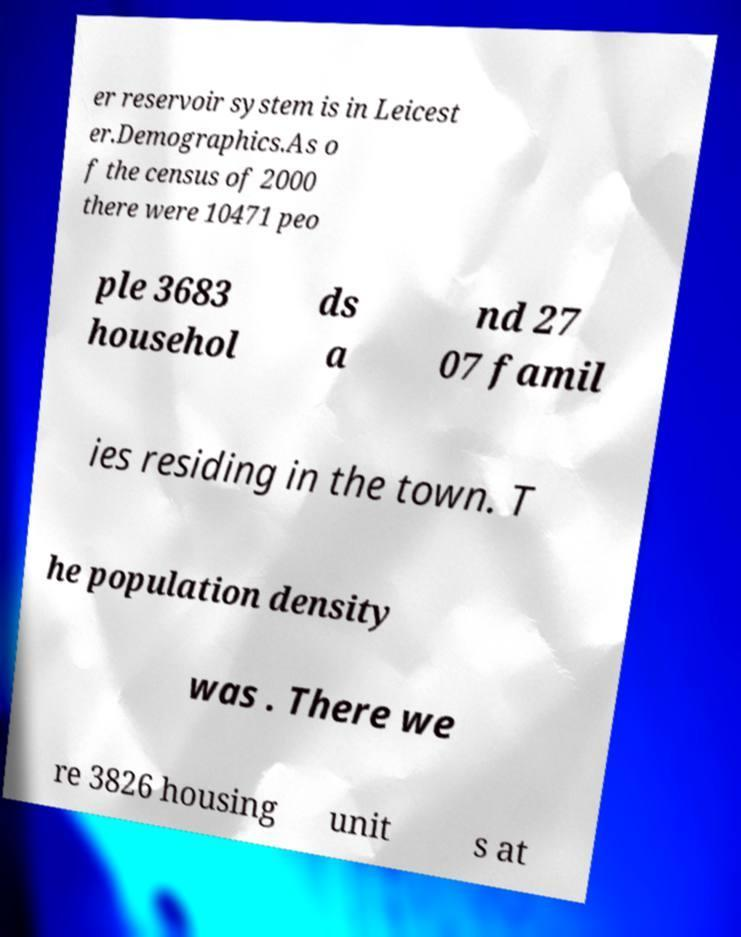Could you extract and type out the text from this image? er reservoir system is in Leicest er.Demographics.As o f the census of 2000 there were 10471 peo ple 3683 househol ds a nd 27 07 famil ies residing in the town. T he population density was . There we re 3826 housing unit s at 